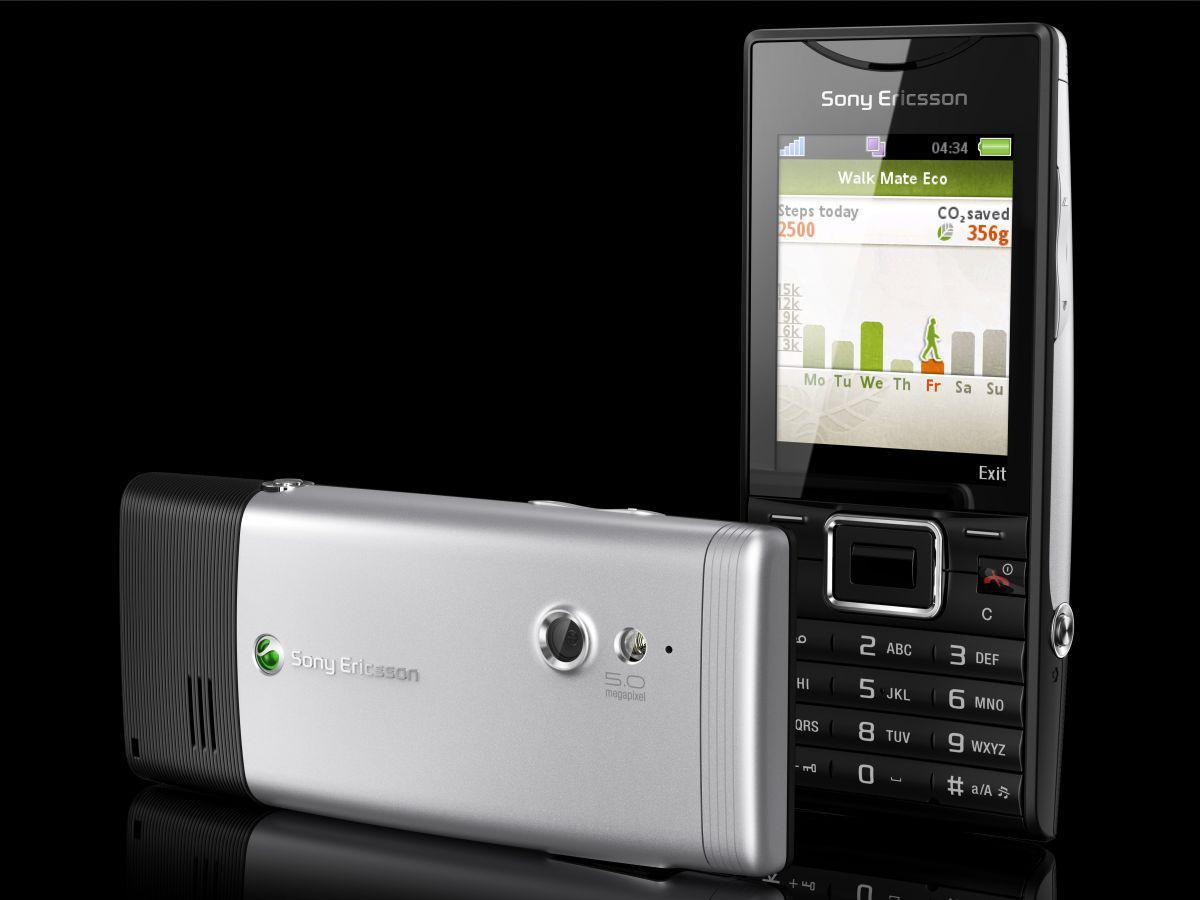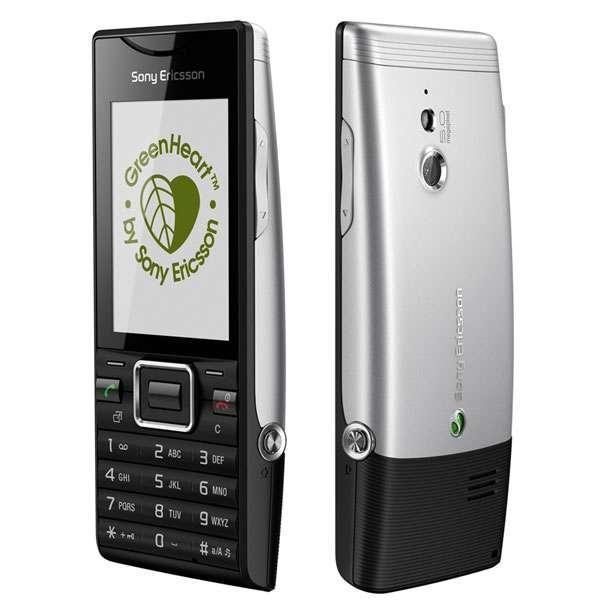The first image is the image on the left, the second image is the image on the right. For the images shown, is this caption "The left and right image contains the same number of phones." true? Answer yes or no. Yes. 